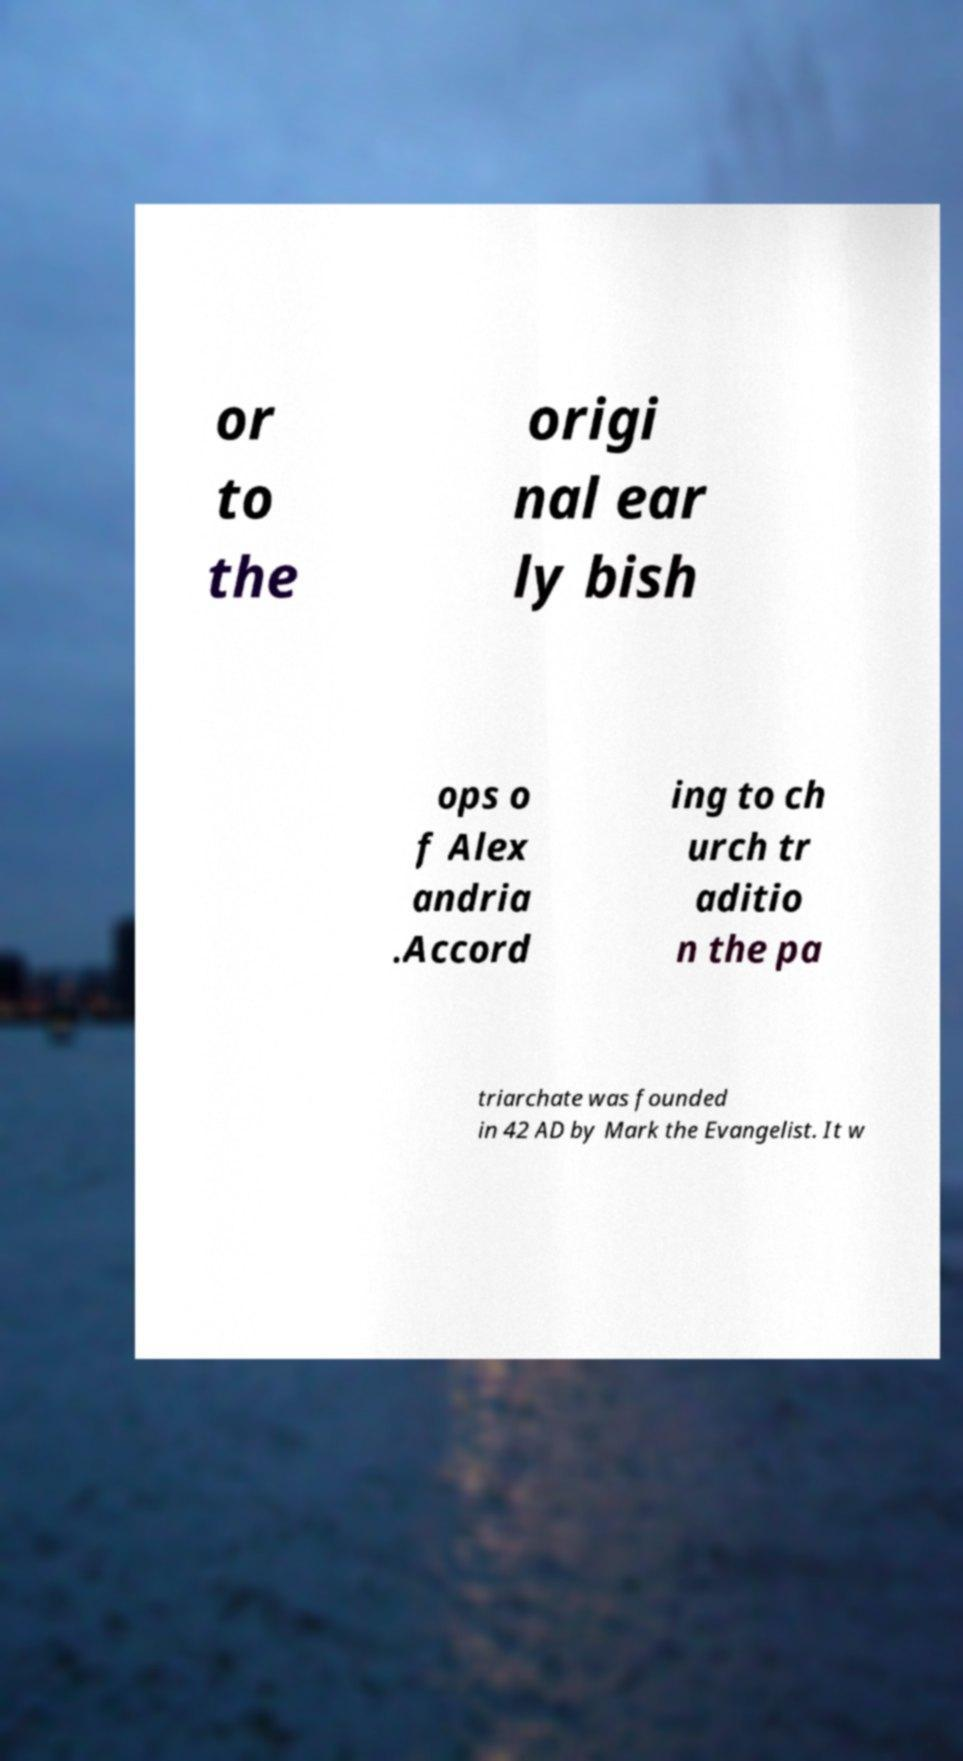Can you read and provide the text displayed in the image?This photo seems to have some interesting text. Can you extract and type it out for me? or to the origi nal ear ly bish ops o f Alex andria .Accord ing to ch urch tr aditio n the pa triarchate was founded in 42 AD by Mark the Evangelist. It w 